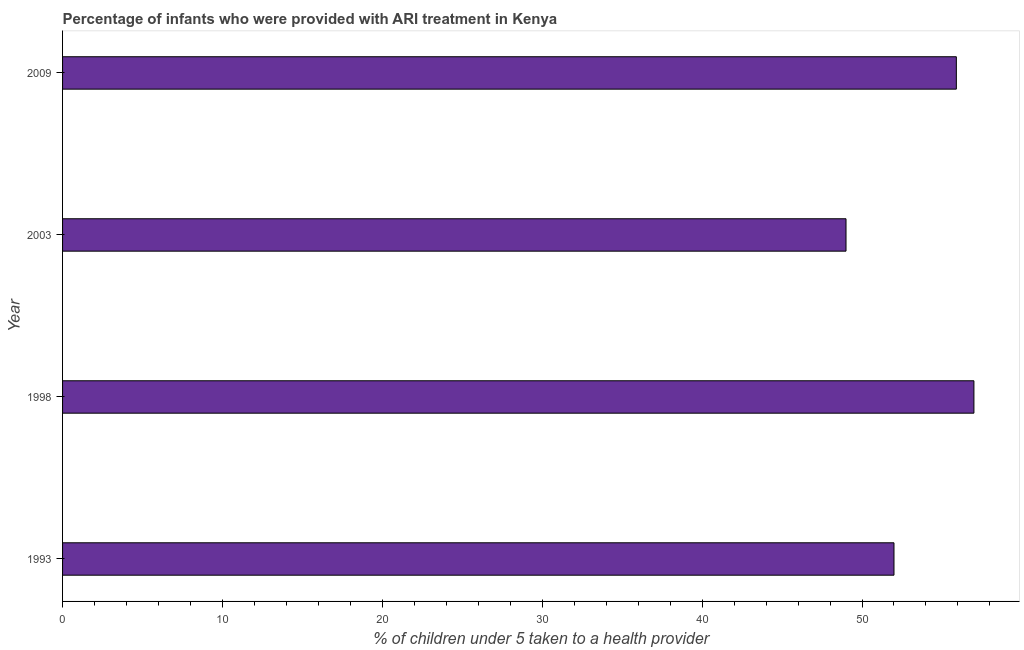Does the graph contain any zero values?
Your answer should be compact. No. Does the graph contain grids?
Make the answer very short. No. What is the title of the graph?
Provide a succinct answer. Percentage of infants who were provided with ARI treatment in Kenya. What is the label or title of the X-axis?
Your response must be concise. % of children under 5 taken to a health provider. What is the sum of the percentage of children who were provided with ari treatment?
Ensure brevity in your answer.  213.9. What is the difference between the percentage of children who were provided with ari treatment in 1993 and 2009?
Your answer should be compact. -3.9. What is the average percentage of children who were provided with ari treatment per year?
Provide a short and direct response. 53.48. What is the median percentage of children who were provided with ari treatment?
Your response must be concise. 53.95. In how many years, is the percentage of children who were provided with ari treatment greater than 22 %?
Offer a very short reply. 4. What is the ratio of the percentage of children who were provided with ari treatment in 1998 to that in 2003?
Give a very brief answer. 1.16. Is the percentage of children who were provided with ari treatment in 1998 less than that in 2009?
Your answer should be compact. No. Is the difference between the percentage of children who were provided with ari treatment in 1993 and 2003 greater than the difference between any two years?
Your answer should be compact. No. What is the difference between the highest and the lowest percentage of children who were provided with ari treatment?
Your response must be concise. 8. How many bars are there?
Provide a short and direct response. 4. How many years are there in the graph?
Offer a very short reply. 4. What is the % of children under 5 taken to a health provider of 1998?
Give a very brief answer. 57. What is the % of children under 5 taken to a health provider of 2003?
Give a very brief answer. 49. What is the % of children under 5 taken to a health provider in 2009?
Give a very brief answer. 55.9. What is the difference between the % of children under 5 taken to a health provider in 1993 and 2009?
Provide a succinct answer. -3.9. What is the difference between the % of children under 5 taken to a health provider in 1998 and 2009?
Offer a terse response. 1.1. What is the difference between the % of children under 5 taken to a health provider in 2003 and 2009?
Your response must be concise. -6.9. What is the ratio of the % of children under 5 taken to a health provider in 1993 to that in 1998?
Make the answer very short. 0.91. What is the ratio of the % of children under 5 taken to a health provider in 1993 to that in 2003?
Ensure brevity in your answer.  1.06. What is the ratio of the % of children under 5 taken to a health provider in 1998 to that in 2003?
Give a very brief answer. 1.16. What is the ratio of the % of children under 5 taken to a health provider in 2003 to that in 2009?
Offer a very short reply. 0.88. 